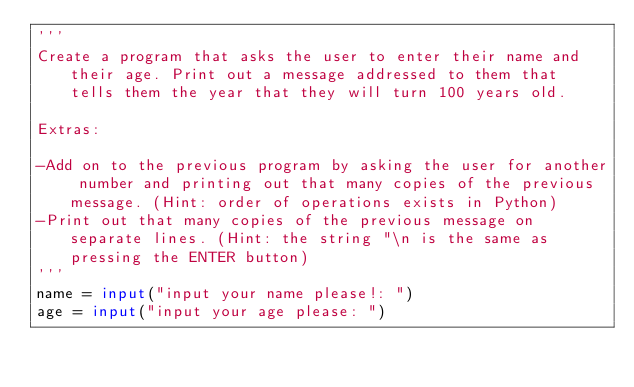<code> <loc_0><loc_0><loc_500><loc_500><_Python_>'''
Create a program that asks the user to enter their name and their age. Print out a message addressed to them that tells them the year that they will turn 100 years old.

Extras:

-Add on to the previous program by asking the user for another number and printing out that many copies of the previous message. (Hint: order of operations exists in Python)
-Print out that many copies of the previous message on separate lines. (Hint: the string "\n is the same as pressing the ENTER button)
'''
name = input("input your name please!: ")
age = input("input your age please: ")</code> 